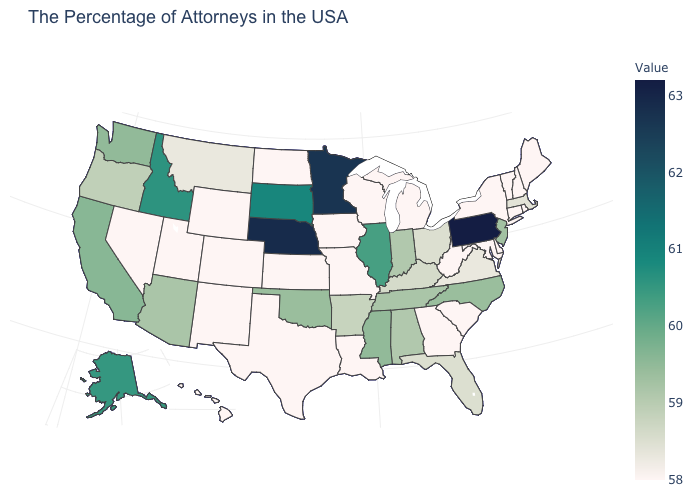Which states have the lowest value in the West?
Quick response, please. Wyoming, Colorado, New Mexico, Utah, Nevada, Hawaii. Is the legend a continuous bar?
Keep it brief. Yes. Which states have the highest value in the USA?
Keep it brief. Pennsylvania. Which states have the highest value in the USA?
Answer briefly. Pennsylvania. Among the states that border Connecticut , which have the highest value?
Give a very brief answer. Massachusetts. Does Pennsylvania have the highest value in the USA?
Be succinct. Yes. 